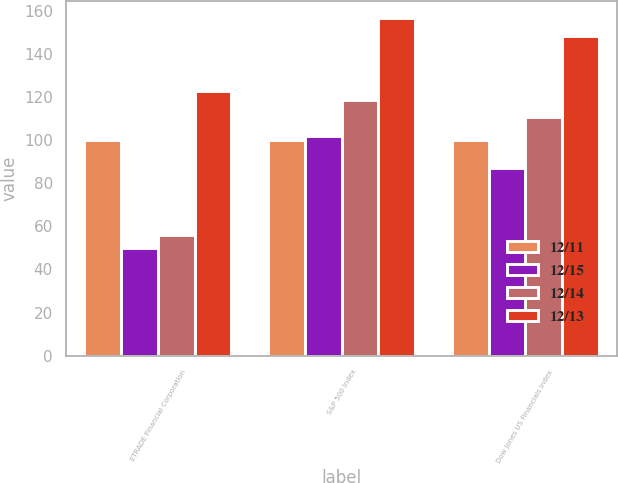Convert chart to OTSL. <chart><loc_0><loc_0><loc_500><loc_500><stacked_bar_chart><ecel><fcel>ETRADE Financial Corporation<fcel>S&P 500 Index<fcel>Dow Jones US Financials Index<nl><fcel>12/11<fcel>100<fcel>100<fcel>100<nl><fcel>12/15<fcel>49.75<fcel>102.11<fcel>87.16<nl><fcel>12/14<fcel>55.94<fcel>118.45<fcel>110.56<nl><fcel>12/13<fcel>122.75<fcel>156.82<fcel>148.39<nl></chart> 